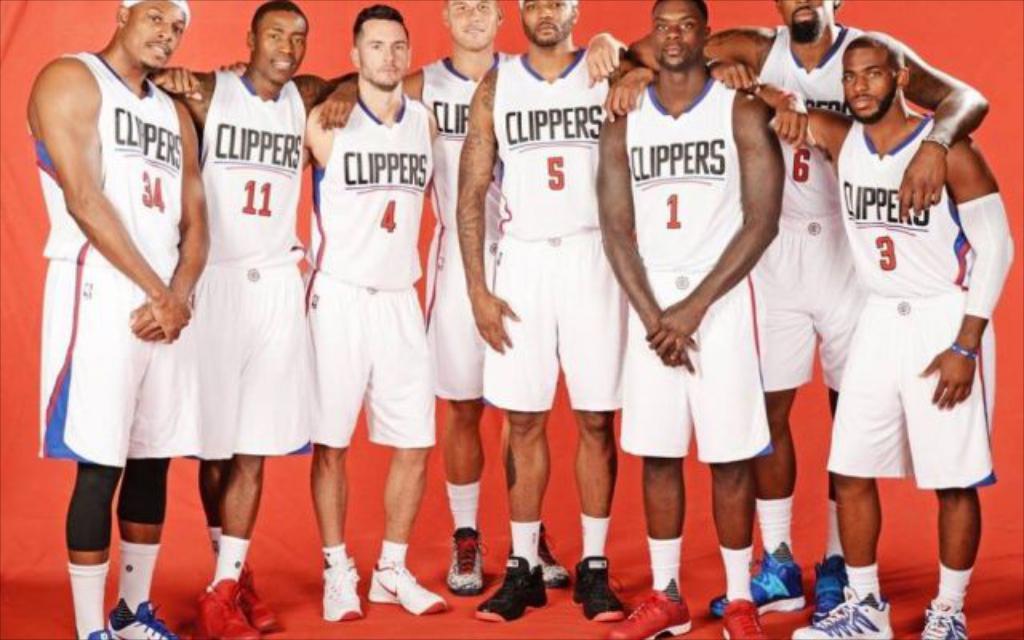Describe this image in one or two sentences. In this picture there are persons standing and wearing a white colour shirts with some text and numbers written on it. In the background there is a curtain which is red in colour. 